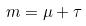<formula> <loc_0><loc_0><loc_500><loc_500>m = \mu + \tau</formula> 